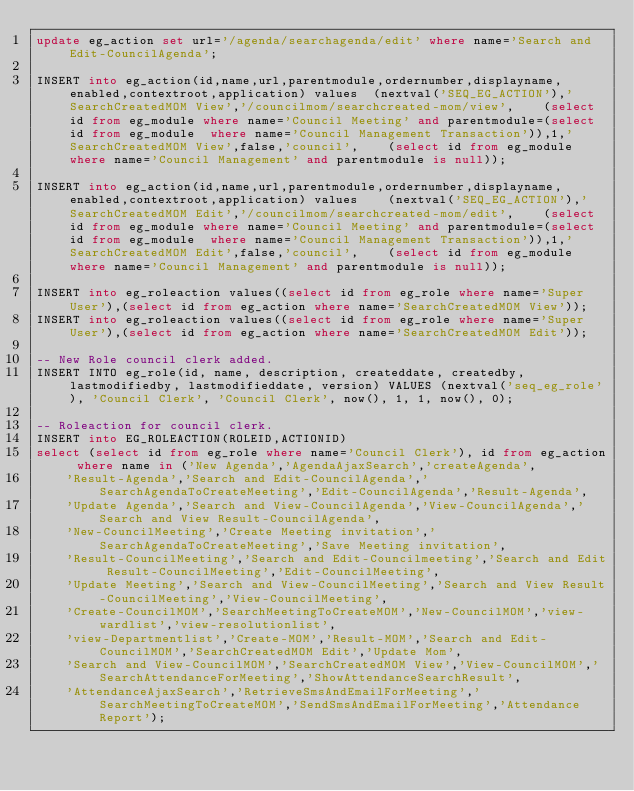Convert code to text. <code><loc_0><loc_0><loc_500><loc_500><_SQL_>update eg_action set url='/agenda/searchagenda/edit' where name='Search and Edit-CouncilAgenda';

INSERT into eg_action(id,name,url,parentmodule,ordernumber,displayname,enabled,contextroot,application) values  (nextval('SEQ_EG_ACTION'),'SearchCreatedMOM View','/councilmom/searchcreated-mom/view',    (select id from eg_module where name='Council Meeting' and parentmodule=(select id from eg_module  where name='Council Management Transaction')),1,'SearchCreatedMOM View',false,'council',    (select id from eg_module where name='Council Management' and parentmodule is null));

INSERT into eg_action(id,name,url,parentmodule,ordernumber,displayname,enabled,contextroot,application) values    (nextval('SEQ_EG_ACTION'),'SearchCreatedMOM Edit','/councilmom/searchcreated-mom/edit',    (select id from eg_module where name='Council Meeting' and parentmodule=(select id from eg_module  where name='Council Management Transaction')),1,'SearchCreatedMOM Edit',false,'council',    (select id from eg_module where name='Council Management' and parentmodule is null));

INSERT into eg_roleaction values((select id from eg_role where name='Super User'),(select id from eg_action where name='SearchCreatedMOM View'));
INSERT into eg_roleaction values((select id from eg_role where name='Super User'),(select id from eg_action where name='SearchCreatedMOM Edit'));

-- New Role council clerk added.
INSERT INTO eg_role(id, name, description, createddate, createdby, lastmodifiedby, lastmodifieddate, version) VALUES (nextval('seq_eg_role'), 'Council Clerk', 'Council Clerk', now(), 1, 1, now(), 0);

-- Roleaction for council clerk.
INSERT into EG_ROLEACTION(ROLEID,ACTIONID) 
select (select id from eg_role where name='Council Clerk'), id from eg_action where name in ('New Agenda','AgendaAjaxSearch','createAgenda',
	'Result-Agenda','Search and Edit-CouncilAgenda','SearchAgendaToCreateMeeting','Edit-CouncilAgenda','Result-Agenda',
	'Update Agenda','Search and View-CouncilAgenda','View-CouncilAgenda','Search and View Result-CouncilAgenda',
	'New-CouncilMeeting','Create Meeting invitation','SearchAgendaToCreateMeeting','Save Meeting invitation',
	'Result-CouncilMeeting','Search and Edit-Councilmeeting','Search and Edit Result-CouncilMeeting','Edit-CouncilMeeting',
	'Update Meeting','Search and View-CouncilMeeting','Search and View Result-CouncilMeeting','View-CouncilMeeting',
	'Create-CouncilMOM','SearchMeetingToCreateMOM','New-CouncilMOM','view-wardlist','view-resolutionlist',
	'view-Departmentlist','Create-MOM','Result-MOM','Search and Edit-CouncilMOM','SearchCreatedMOM Edit','Update Mom',
	'Search and View-CouncilMOM','SearchCreatedMOM View','View-CouncilMOM','SearchAttendanceForMeeting','ShowAttendanceSearchResult',
	'AttendanceAjaxSearch','RetrieveSmsAndEmailForMeeting','SearchMeetingToCreateMOM','SendSmsAndEmailForMeeting','Attendance Report');

</code> 